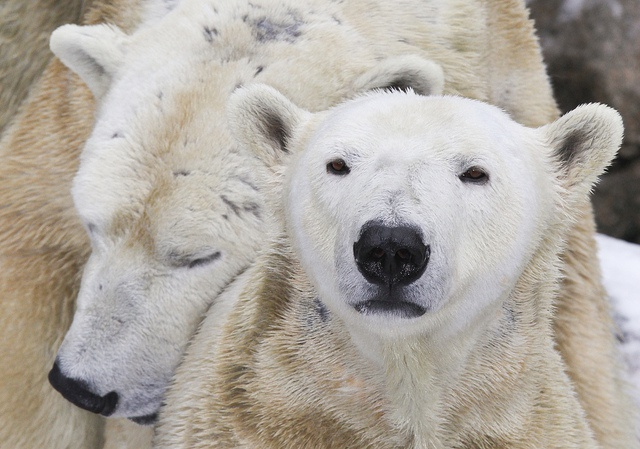Describe the objects in this image and their specific colors. I can see bear in gray, darkgray, and lightgray tones and bear in gray, darkgray, and lightgray tones in this image. 